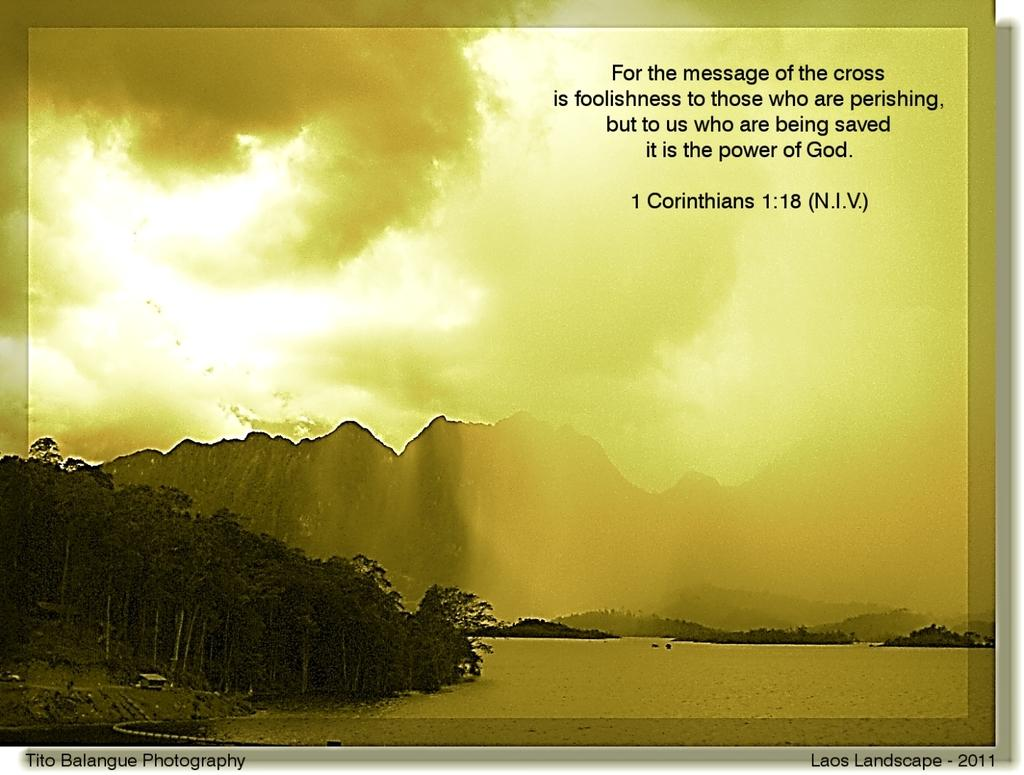<image>
Write a terse but informative summary of the picture. a quote from Corinthians is on the photo of the mountain 